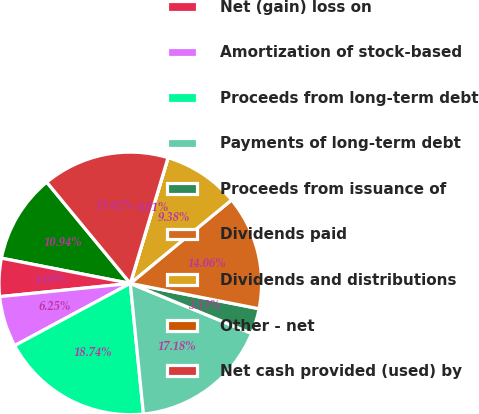<chart> <loc_0><loc_0><loc_500><loc_500><pie_chart><fcel>Net income (loss)<fcel>Net (gain) loss on<fcel>Amortization of stock-based<fcel>Proceeds from long-term debt<fcel>Payments of long-term debt<fcel>Proceeds from issuance of<fcel>Dividends paid<fcel>Dividends and distributions<fcel>Other - net<fcel>Net cash provided (used) by<nl><fcel>10.94%<fcel>4.69%<fcel>6.25%<fcel>18.74%<fcel>17.18%<fcel>3.13%<fcel>14.06%<fcel>9.38%<fcel>0.01%<fcel>15.62%<nl></chart> 